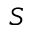Convert formula to latex. <formula><loc_0><loc_0><loc_500><loc_500>S</formula> 